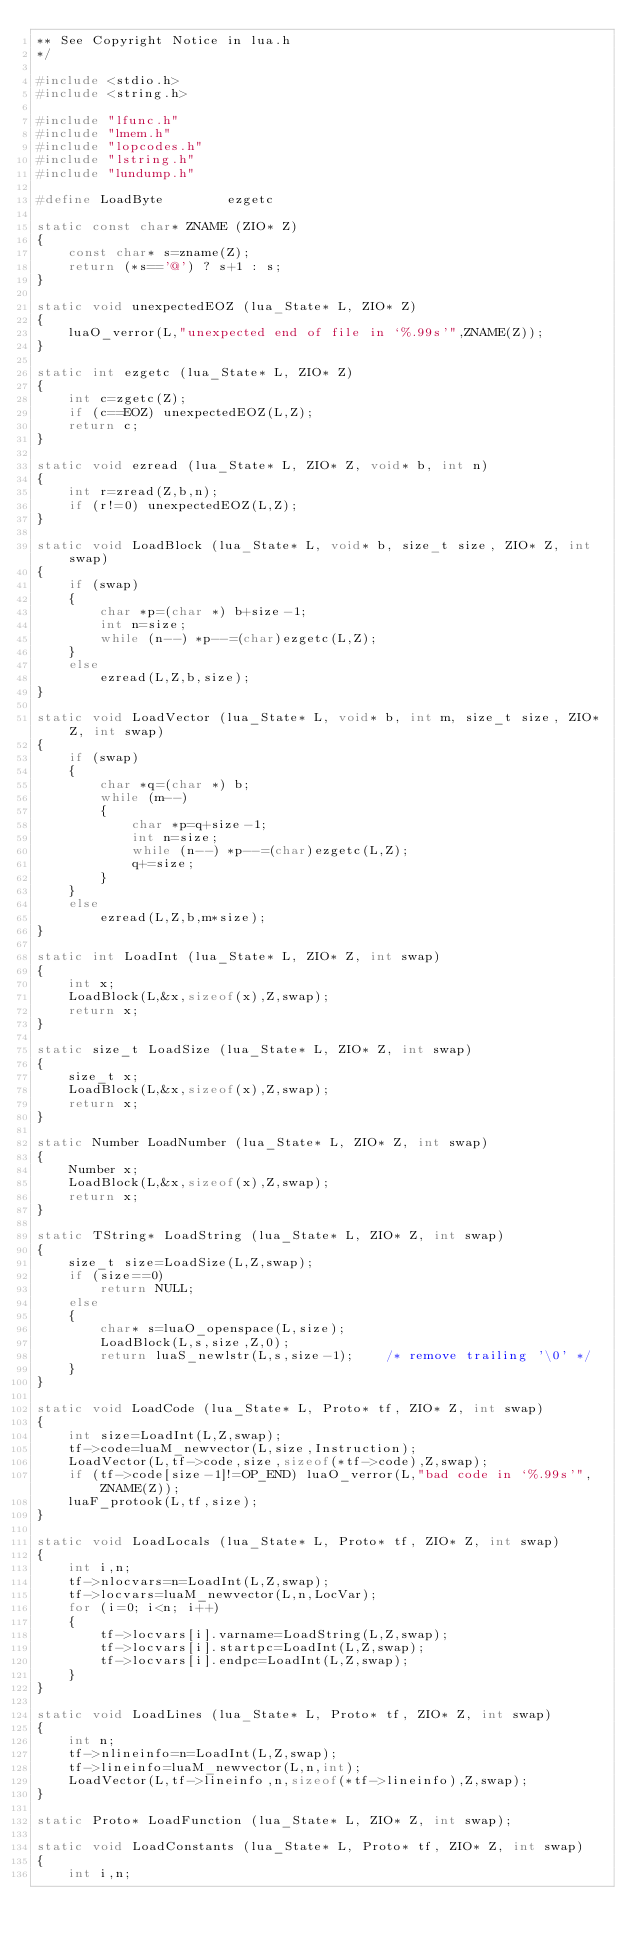<code> <loc_0><loc_0><loc_500><loc_500><_C++_>** See Copyright Notice in lua.h
*/

#include <stdio.h>
#include <string.h>

#include "lfunc.h"
#include "lmem.h"
#include "lopcodes.h"
#include "lstring.h"
#include "lundump.h"

#define	LoadByte		ezgetc

static const char* ZNAME (ZIO* Z)
{
    const char* s=zname(Z);
    return (*s=='@') ? s+1 : s;
}

static void unexpectedEOZ (lua_State* L, ZIO* Z)
{
    luaO_verror(L,"unexpected end of file in `%.99s'",ZNAME(Z));
}

static int ezgetc (lua_State* L, ZIO* Z)
{
    int c=zgetc(Z);
    if (c==EOZ) unexpectedEOZ(L,Z);
    return c;
}

static void ezread (lua_State* L, ZIO* Z, void* b, int n)
{
    int r=zread(Z,b,n);
    if (r!=0) unexpectedEOZ(L,Z);
}

static void LoadBlock (lua_State* L, void* b, size_t size, ZIO* Z, int swap)
{
    if (swap)
    {
        char *p=(char *) b+size-1;
        int n=size;
        while (n--) *p--=(char)ezgetc(L,Z);
    }
    else
        ezread(L,Z,b,size);
}

static void LoadVector (lua_State* L, void* b, int m, size_t size, ZIO* Z, int swap)
{
    if (swap)
    {
        char *q=(char *) b;
        while (m--)
        {
            char *p=q+size-1;
            int n=size;
            while (n--) *p--=(char)ezgetc(L,Z);
            q+=size;
        }
    }
    else
        ezread(L,Z,b,m*size);
}

static int LoadInt (lua_State* L, ZIO* Z, int swap)
{
    int x;
    LoadBlock(L,&x,sizeof(x),Z,swap);
    return x;
}

static size_t LoadSize (lua_State* L, ZIO* Z, int swap)
{
    size_t x;
    LoadBlock(L,&x,sizeof(x),Z,swap);
    return x;
}

static Number LoadNumber (lua_State* L, ZIO* Z, int swap)
{
    Number x;
    LoadBlock(L,&x,sizeof(x),Z,swap);
    return x;
}

static TString* LoadString (lua_State* L, ZIO* Z, int swap)
{
    size_t size=LoadSize(L,Z,swap);
    if (size==0)
        return NULL;
    else
    {
        char* s=luaO_openspace(L,size);
        LoadBlock(L,s,size,Z,0);
        return luaS_newlstr(L,s,size-1);	/* remove trailing '\0' */
    }
}

static void LoadCode (lua_State* L, Proto* tf, ZIO* Z, int swap)
{
    int size=LoadInt(L,Z,swap);
    tf->code=luaM_newvector(L,size,Instruction);
    LoadVector(L,tf->code,size,sizeof(*tf->code),Z,swap);
    if (tf->code[size-1]!=OP_END) luaO_verror(L,"bad code in `%.99s'",ZNAME(Z));
    luaF_protook(L,tf,size);
}

static void LoadLocals (lua_State* L, Proto* tf, ZIO* Z, int swap)
{
    int i,n;
    tf->nlocvars=n=LoadInt(L,Z,swap);
    tf->locvars=luaM_newvector(L,n,LocVar);
    for (i=0; i<n; i++)
    {
        tf->locvars[i].varname=LoadString(L,Z,swap);
        tf->locvars[i].startpc=LoadInt(L,Z,swap);
        tf->locvars[i].endpc=LoadInt(L,Z,swap);
    }
}

static void LoadLines (lua_State* L, Proto* tf, ZIO* Z, int swap)
{
    int n;
    tf->nlineinfo=n=LoadInt(L,Z,swap);
    tf->lineinfo=luaM_newvector(L,n,int);
    LoadVector(L,tf->lineinfo,n,sizeof(*tf->lineinfo),Z,swap);
}

static Proto* LoadFunction (lua_State* L, ZIO* Z, int swap);

static void LoadConstants (lua_State* L, Proto* tf, ZIO* Z, int swap)
{
    int i,n;</code> 